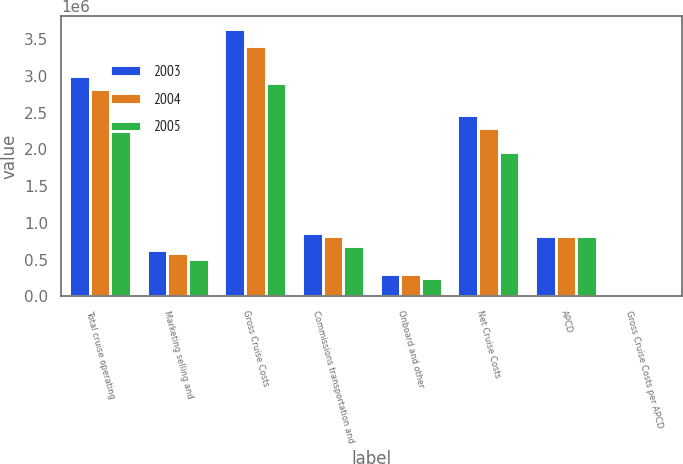<chart> <loc_0><loc_0><loc_500><loc_500><stacked_bar_chart><ecel><fcel>Total cruise operating<fcel>Marketing selling and<fcel>Gross Cruise Costs<fcel>Commissions transportation and<fcel>Onboard and other<fcel>Net Cruise Costs<fcel>APCD<fcel>Gross Cruise Costs per APCD<nl><fcel>2003<fcel>2.99423e+06<fcel>635308<fcel>3.62954e+06<fcel>858606<fcel>308611<fcel>2.46232e+06<fcel>822206<fcel>167<nl><fcel>2004<fcel>2.81938e+06<fcel>588267<fcel>3.40765e+06<fcel>822206<fcel>300717<fcel>2.28473e+06<fcel>822206<fcel>158.94<nl><fcel>2005<fcel>2.38104e+06<fcel>514334<fcel>2.89537e+06<fcel>684344<fcel>249537<fcel>1.96149e+06<fcel>822206<fcel>148.94<nl></chart> 